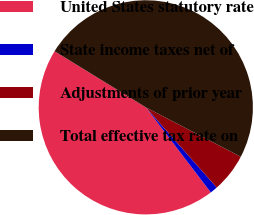Convert chart. <chart><loc_0><loc_0><loc_500><loc_500><pie_chart><fcel>United States statutory rate<fcel>State income taxes net of<fcel>Adjustments of prior year<fcel>Total effective tax rate on<nl><fcel>44.16%<fcel>1.14%<fcel>5.84%<fcel>48.86%<nl></chart> 